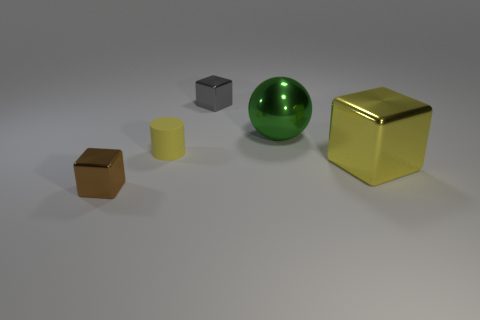What number of yellow metallic cubes have the same size as the green thing?
Provide a short and direct response. 1. Are there fewer tiny brown cubes right of the tiny yellow matte cylinder than tiny metal blocks in front of the yellow metal object?
Your response must be concise. Yes. What number of matte objects are small brown things or tiny spheres?
Ensure brevity in your answer.  0. What is the shape of the small gray object?
Make the answer very short. Cube. There is a cylinder that is the same size as the gray thing; what material is it?
Offer a terse response. Rubber. How many tiny objects are either yellow cubes or brown metal blocks?
Provide a succinct answer. 1. Are there any gray balls?
Make the answer very short. No. What is the size of the gray block that is made of the same material as the small brown thing?
Offer a very short reply. Small. Does the big cube have the same material as the cylinder?
Provide a succinct answer. No. How many other objects are the same material as the cylinder?
Make the answer very short. 0. 